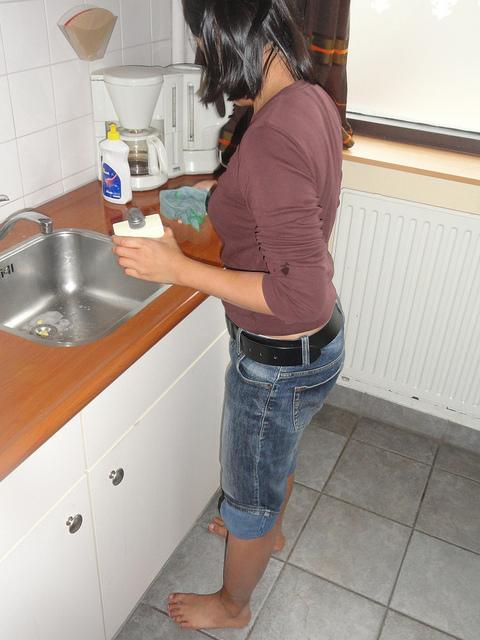What is this room most likely called?

Choices:
A) dining room
B) family room
C) utility room
D) bedroom utility room 